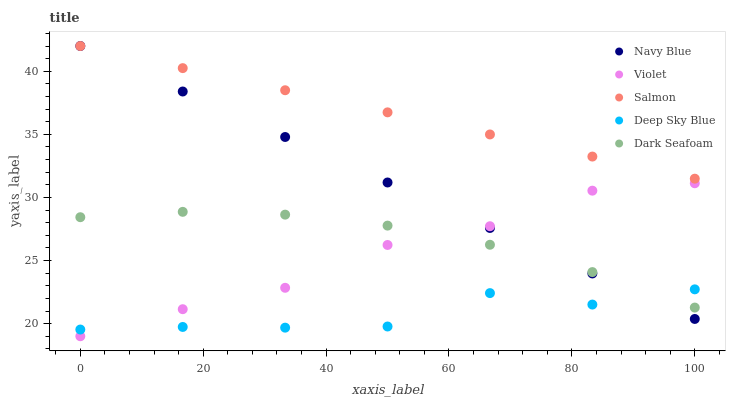Does Deep Sky Blue have the minimum area under the curve?
Answer yes or no. Yes. Does Salmon have the maximum area under the curve?
Answer yes or no. Yes. Does Dark Seafoam have the minimum area under the curve?
Answer yes or no. No. Does Dark Seafoam have the maximum area under the curve?
Answer yes or no. No. Is Salmon the smoothest?
Answer yes or no. Yes. Is Deep Sky Blue the roughest?
Answer yes or no. Yes. Is Dark Seafoam the smoothest?
Answer yes or no. No. Is Dark Seafoam the roughest?
Answer yes or no. No. Does Violet have the lowest value?
Answer yes or no. Yes. Does Dark Seafoam have the lowest value?
Answer yes or no. No. Does Salmon have the highest value?
Answer yes or no. Yes. Does Dark Seafoam have the highest value?
Answer yes or no. No. Is Deep Sky Blue less than Salmon?
Answer yes or no. Yes. Is Salmon greater than Deep Sky Blue?
Answer yes or no. Yes. Does Dark Seafoam intersect Navy Blue?
Answer yes or no. Yes. Is Dark Seafoam less than Navy Blue?
Answer yes or no. No. Is Dark Seafoam greater than Navy Blue?
Answer yes or no. No. Does Deep Sky Blue intersect Salmon?
Answer yes or no. No. 